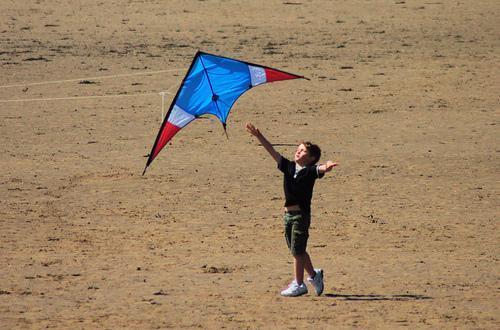How many people are in the photo?
Give a very brief answer. 1. 